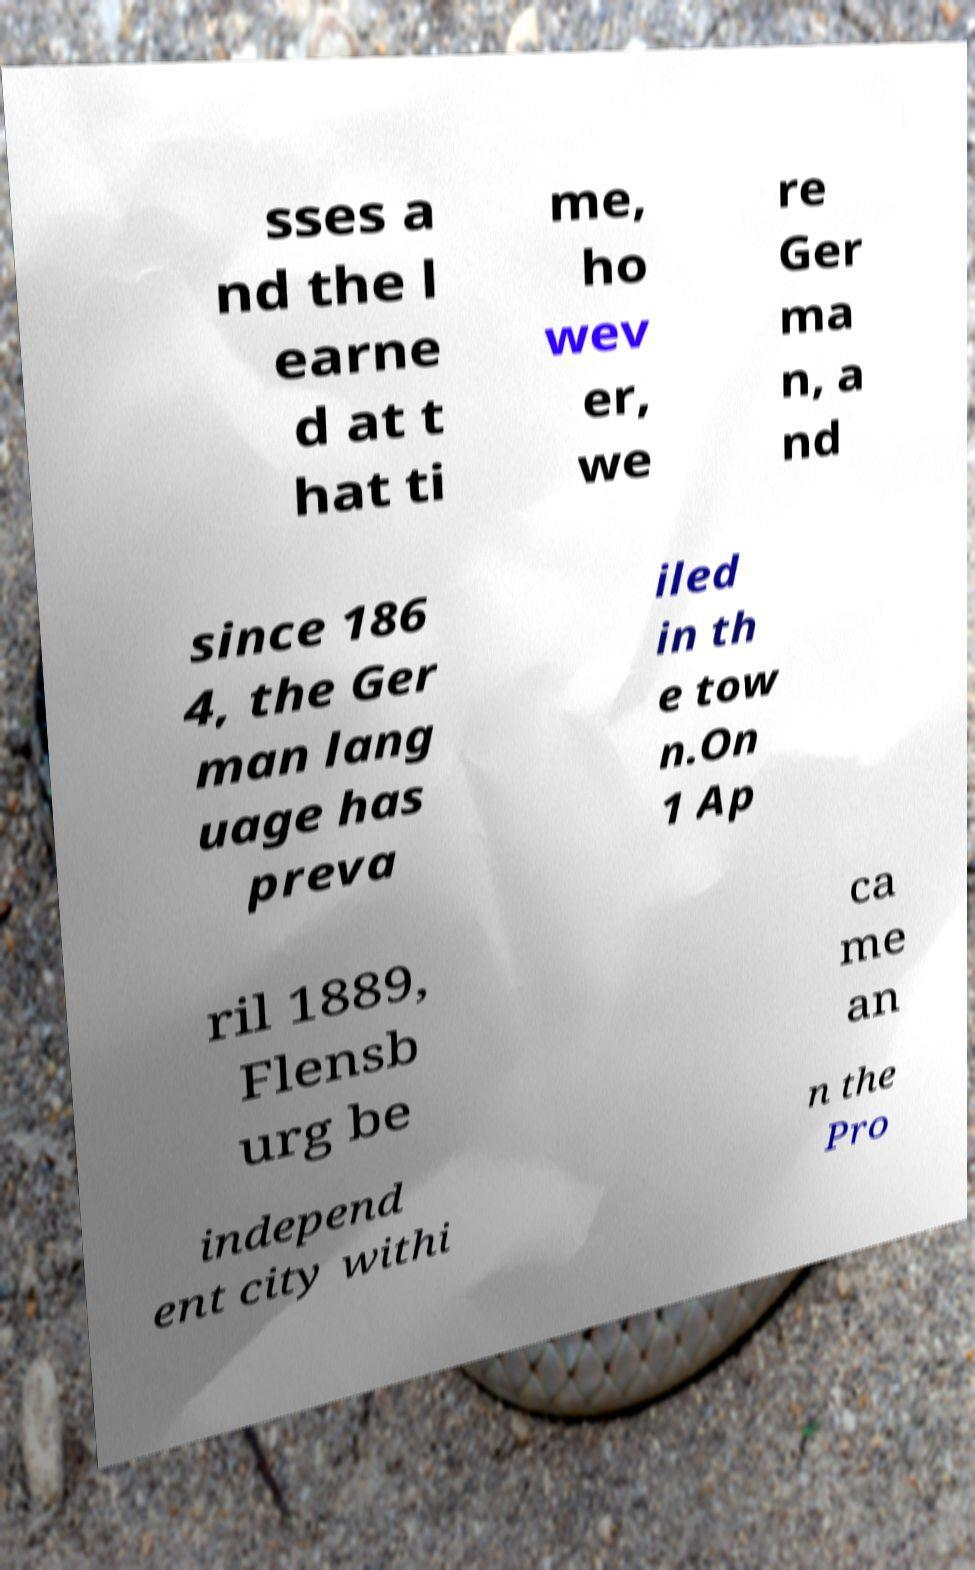Please identify and transcribe the text found in this image. sses a nd the l earne d at t hat ti me, ho wev er, we re Ger ma n, a nd since 186 4, the Ger man lang uage has preva iled in th e tow n.On 1 Ap ril 1889, Flensb urg be ca me an independ ent city withi n the Pro 